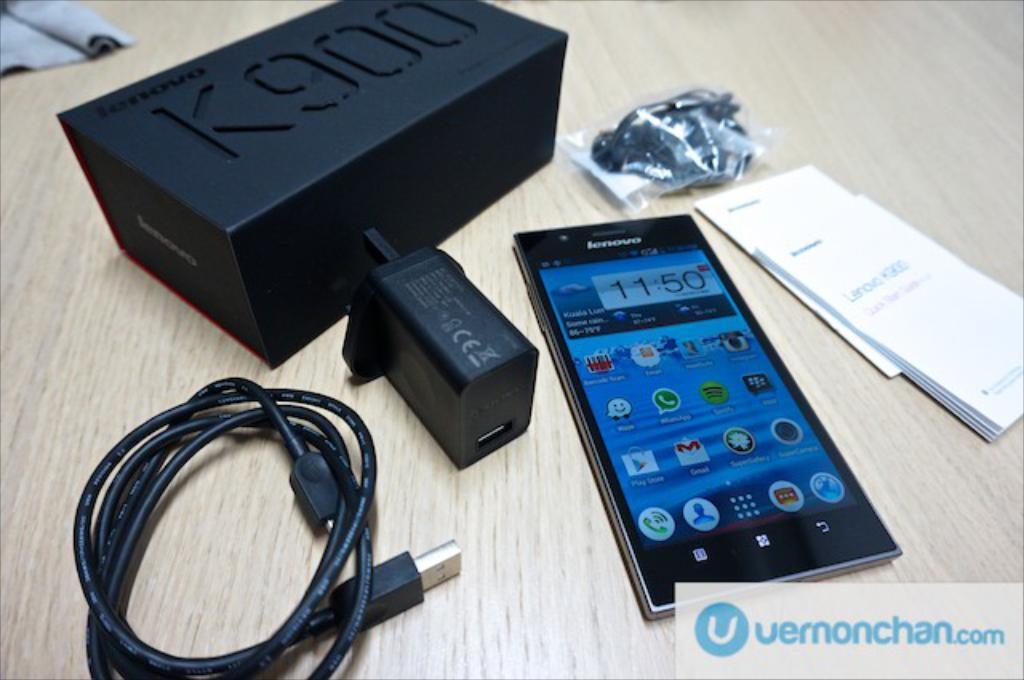Provide a one-sentence caption for the provided image. A Lenovo brand smartphone with cords beside it and a K900 box above the phone. 